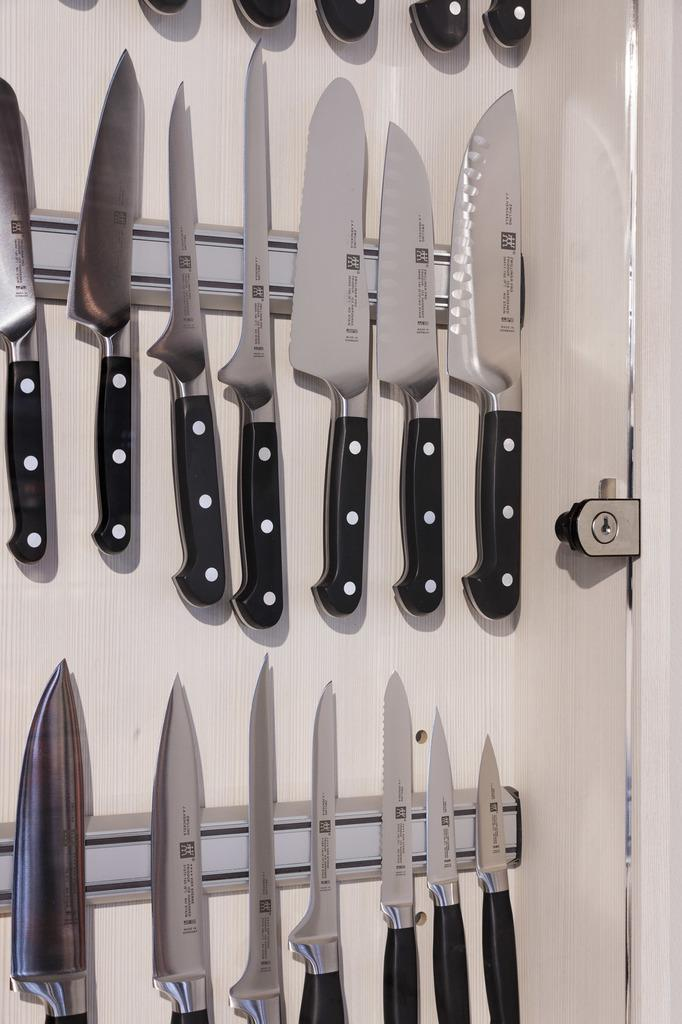What objects can be seen in the image? There are knives in the image. What color is the background of the image? The background of the image is white. Can you see any mice running around the knives in the image? There are no mice present in the image. Where is the faucet located in the image? There is no faucet present in the image. 